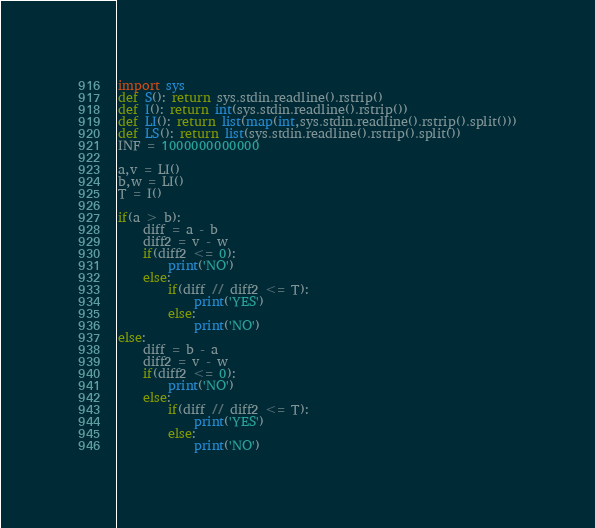<code> <loc_0><loc_0><loc_500><loc_500><_Python_>import sys
def S(): return sys.stdin.readline().rstrip()
def I(): return int(sys.stdin.readline().rstrip())
def LI(): return list(map(int,sys.stdin.readline().rstrip().split()))
def LS(): return list(sys.stdin.readline().rstrip().split())
INF = 1000000000000

a,v = LI()
b,w = LI()
T = I()

if(a > b):
    diff = a - b
    diff2 = v - w
    if(diff2 <= 0):
        print('NO')
    else:
        if(diff // diff2 <= T):
            print('YES')
        else:
            print('NO')
else:
    diff = b - a
    diff2 = v - w
    if(diff2 <= 0):
        print('NO')
    else:
        if(diff // diff2 <= T):
            print('YES')
        else:
            print('NO')
</code> 